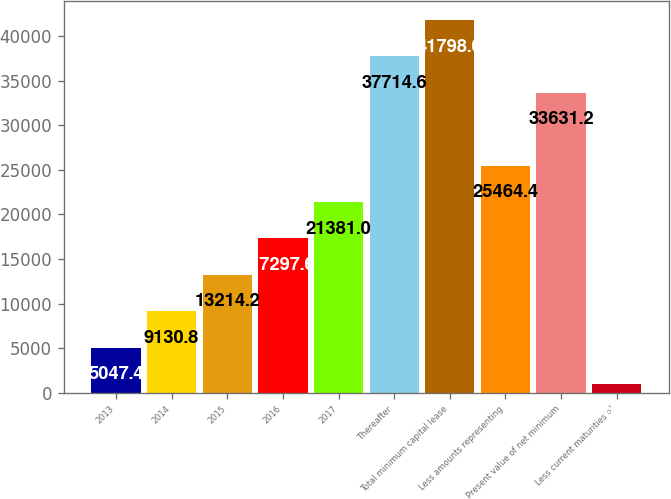<chart> <loc_0><loc_0><loc_500><loc_500><bar_chart><fcel>2013<fcel>2014<fcel>2015<fcel>2016<fcel>2017<fcel>Thereafter<fcel>Total minimum capital lease<fcel>Less amounts representing<fcel>Present value of net minimum<fcel>Less current maturities of<nl><fcel>5047.4<fcel>9130.8<fcel>13214.2<fcel>17297.6<fcel>21381<fcel>37714.6<fcel>41798<fcel>25464.4<fcel>33631.2<fcel>964<nl></chart> 